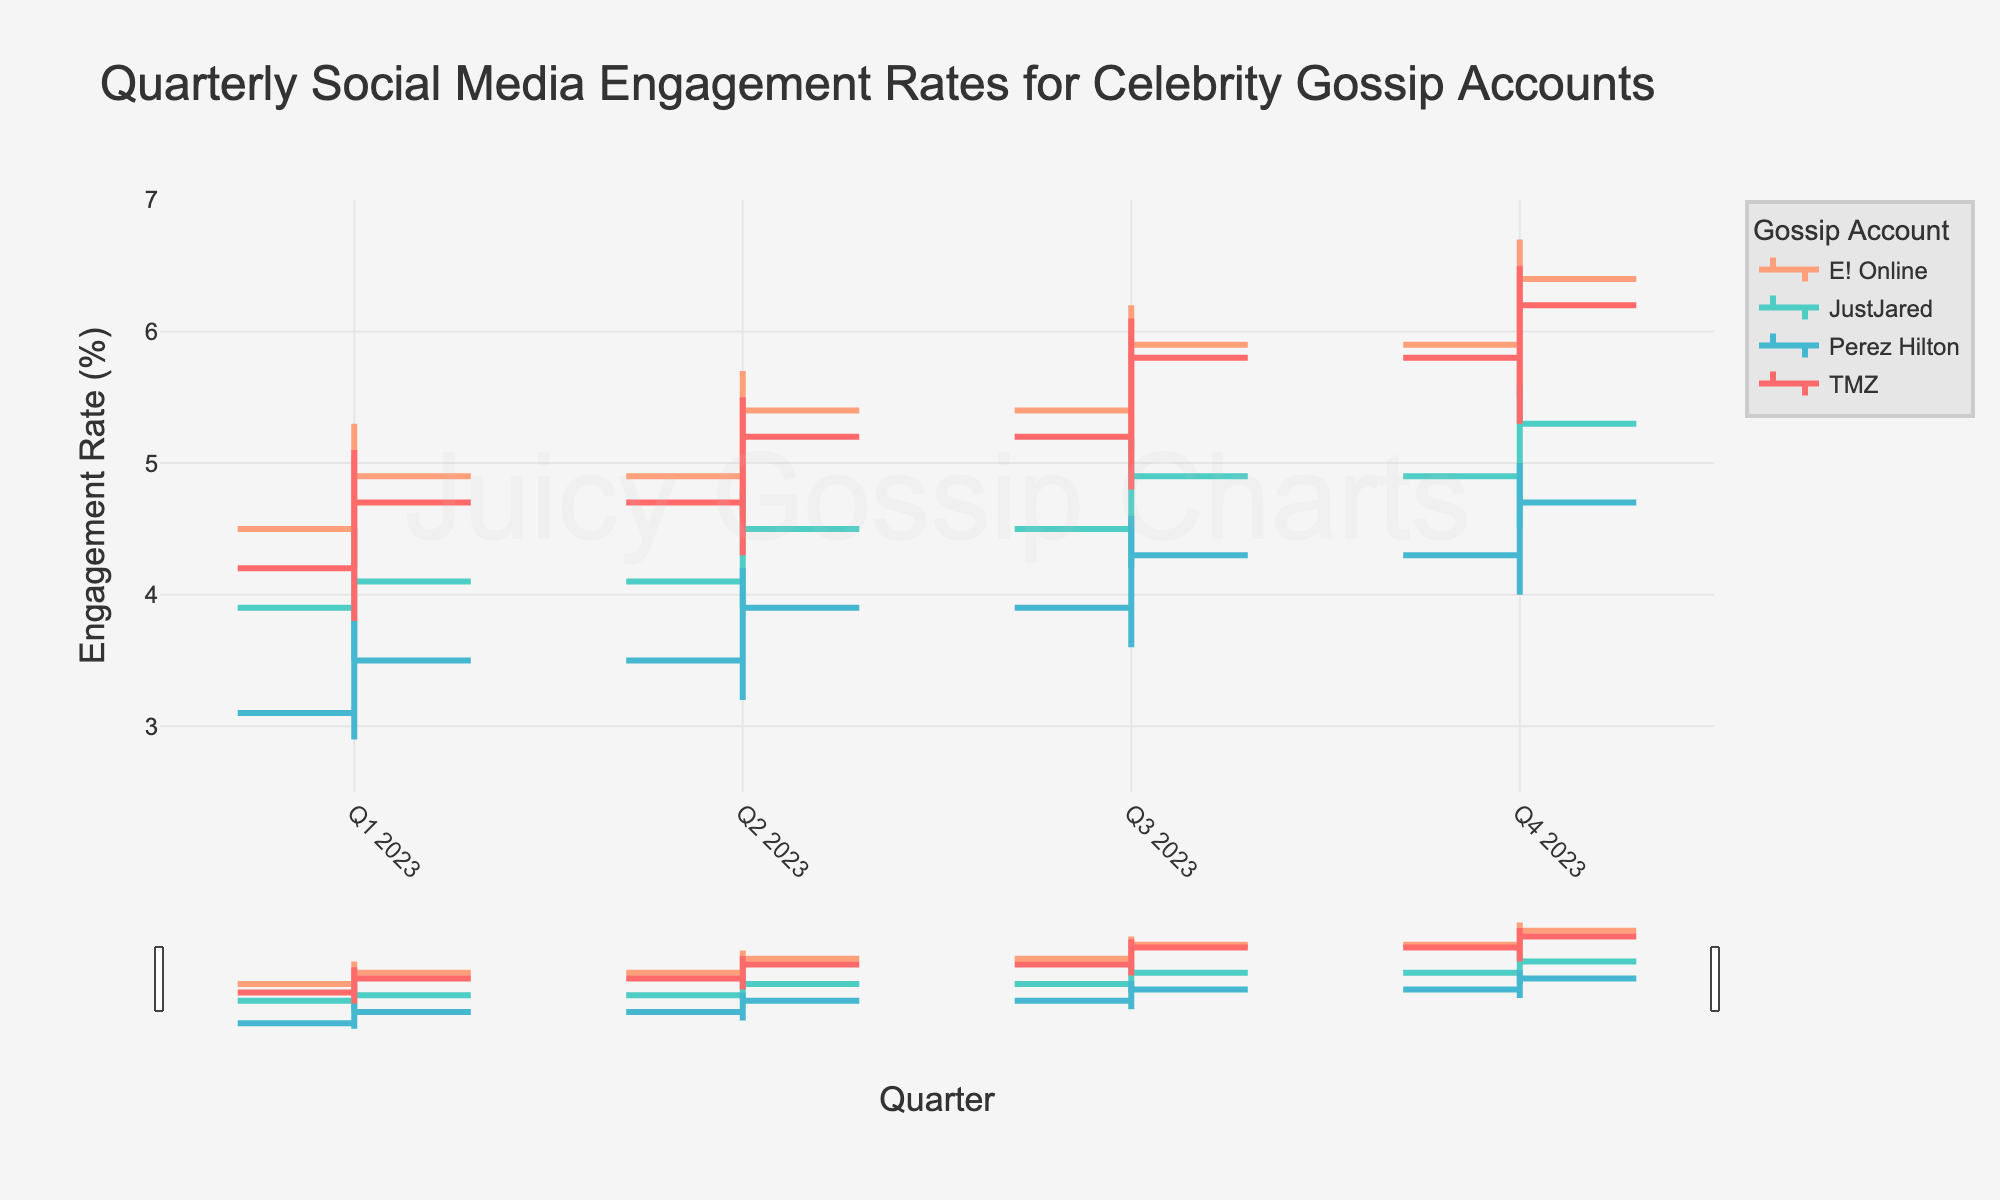what's the title of the chart? The title of the chart is typically at the top of the figure, providing a summary of what the chart represents. In this case, look at the top center of the figure.
Answer: Quarterly Social Media Engagement Rates for Celebrity Gossip Accounts what is the highest engagement rate TMZ achieved in 2023? Find the highest point on the "High" segment for TMZ across all quarters. It appears in Q4 2023.
Answer: 6.5% which account had the largest increase in engagement rate from Q2 2023 to Q3 2023? Compare the "Close" rate of Q2 2023 with the "Open" rate of Q3 2023 for each account and determine which one had the largest difference. E! Online increased from 5.4 to 5.9.
Answer: E! Online what's the difference between the highest and lowest engagement rates for Perez Hilton in Q4 2023? Look at the "High" and "Low" values for Perez Hilton in Q4 2023. Subtract the lowest value from the highest value. 5.0 - 4.0.
Answer: 1.0% which account shows the most consistent upward trend throughout the year? Examine how each account's "Close" value increases or decreases from Q1 to Q4. TMZ shows a consistent upward trend with closing values steadily increasing each quarter.
Answer: TMZ what is the overall trend for JustJared from Q1 to Q4 2023? Observe the "Close" values for JustJared from Q1 to Q4. The engagement rate values are 4.1, 4.5, 4.9, 5.3, showing a consistent upward trend.
Answer: Increasing how much did the engagement rate for E! Online increase from Q1 to Q4 2023? Subtract the "Close" value of Q1 2023 from the "Close" value of Q4 2023 for E! Online. 6.4 - 4.9.
Answer: 1.5% which account had the lowest engagement rate in Q1 2023? Look for the account with the lowest "Close" value in Q1 2023; Perez Hilton had 3.5.
Answer: Perez Hilton in which quarter did JustJared have the highest "High" engagement rate? Compare the "High" values for JustJared across the four quarters and identify the highest one. JustJared had a highest value of 5.6 in Q4.
Answer: Q4 2023 